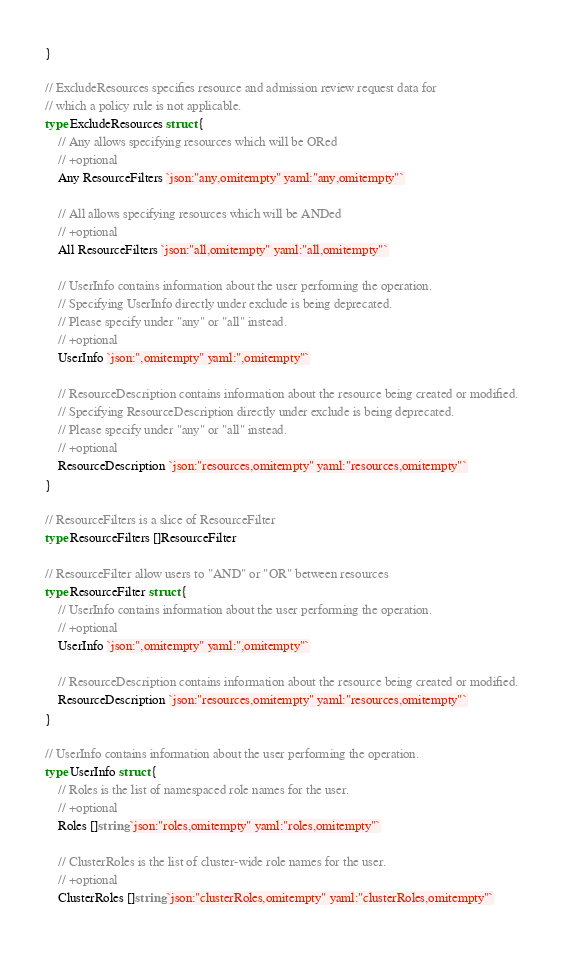Convert code to text. <code><loc_0><loc_0><loc_500><loc_500><_Go_>}

// ExcludeResources specifies resource and admission review request data for
// which a policy rule is not applicable.
type ExcludeResources struct {
	// Any allows specifying resources which will be ORed
	// +optional
	Any ResourceFilters `json:"any,omitempty" yaml:"any,omitempty"`

	// All allows specifying resources which will be ANDed
	// +optional
	All ResourceFilters `json:"all,omitempty" yaml:"all,omitempty"`

	// UserInfo contains information about the user performing the operation.
	// Specifying UserInfo directly under exclude is being deprecated.
	// Please specify under "any" or "all" instead.
	// +optional
	UserInfo `json:",omitempty" yaml:",omitempty"`

	// ResourceDescription contains information about the resource being created or modified.
	// Specifying ResourceDescription directly under exclude is being deprecated.
	// Please specify under "any" or "all" instead.
	// +optional
	ResourceDescription `json:"resources,omitempty" yaml:"resources,omitempty"`
}

// ResourceFilters is a slice of ResourceFilter
type ResourceFilters []ResourceFilter

// ResourceFilter allow users to "AND" or "OR" between resources
type ResourceFilter struct {
	// UserInfo contains information about the user performing the operation.
	// +optional
	UserInfo `json:",omitempty" yaml:",omitempty"`

	// ResourceDescription contains information about the resource being created or modified.
	ResourceDescription `json:"resources,omitempty" yaml:"resources,omitempty"`
}

// UserInfo contains information about the user performing the operation.
type UserInfo struct {
	// Roles is the list of namespaced role names for the user.
	// +optional
	Roles []string `json:"roles,omitempty" yaml:"roles,omitempty"`

	// ClusterRoles is the list of cluster-wide role names for the user.
	// +optional
	ClusterRoles []string `json:"clusterRoles,omitempty" yaml:"clusterRoles,omitempty"`
</code> 